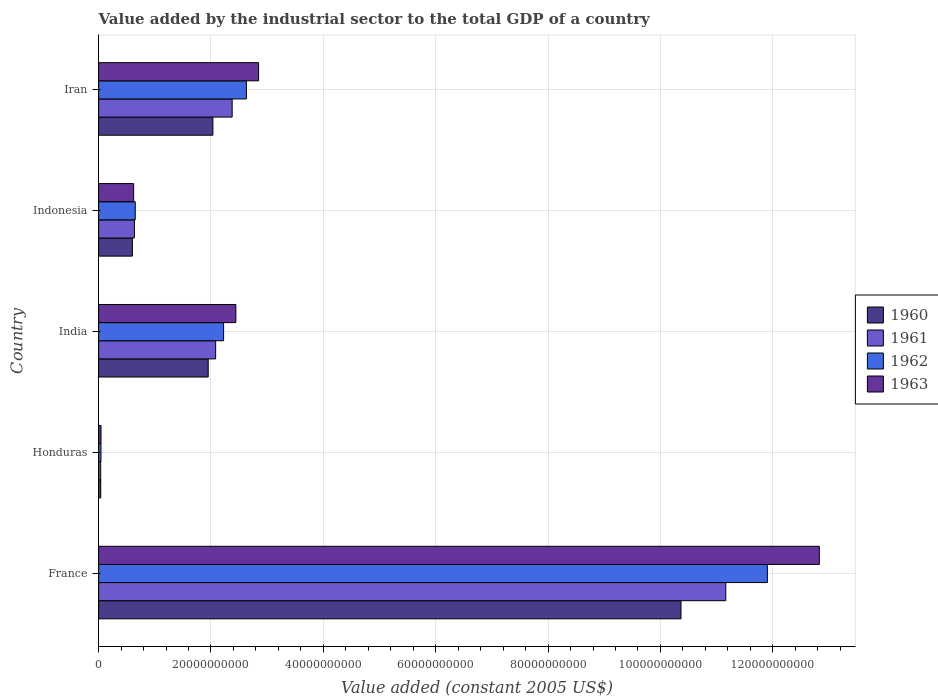How many bars are there on the 1st tick from the bottom?
Your answer should be very brief. 4. What is the value added by the industrial sector in 1960 in Honduras?
Give a very brief answer. 3.75e+08. Across all countries, what is the maximum value added by the industrial sector in 1961?
Keep it short and to the point. 1.12e+11. Across all countries, what is the minimum value added by the industrial sector in 1962?
Your answer should be very brief. 4.16e+08. In which country was the value added by the industrial sector in 1961 minimum?
Your answer should be compact. Honduras. What is the total value added by the industrial sector in 1962 in the graph?
Provide a short and direct response. 1.75e+11. What is the difference between the value added by the industrial sector in 1961 in Honduras and that in Iran?
Your answer should be compact. -2.34e+1. What is the difference between the value added by the industrial sector in 1962 in France and the value added by the industrial sector in 1963 in Honduras?
Keep it short and to the point. 1.19e+11. What is the average value added by the industrial sector in 1962 per country?
Provide a short and direct response. 3.49e+1. What is the difference between the value added by the industrial sector in 1962 and value added by the industrial sector in 1961 in Honduras?
Keep it short and to the point. 5.00e+07. What is the ratio of the value added by the industrial sector in 1961 in Honduras to that in India?
Your response must be concise. 0.02. Is the difference between the value added by the industrial sector in 1962 in Indonesia and Iran greater than the difference between the value added by the industrial sector in 1961 in Indonesia and Iran?
Offer a very short reply. No. What is the difference between the highest and the second highest value added by the industrial sector in 1961?
Your answer should be compact. 8.79e+1. What is the difference between the highest and the lowest value added by the industrial sector in 1961?
Provide a short and direct response. 1.11e+11. In how many countries, is the value added by the industrial sector in 1962 greater than the average value added by the industrial sector in 1962 taken over all countries?
Provide a short and direct response. 1. Is it the case that in every country, the sum of the value added by the industrial sector in 1961 and value added by the industrial sector in 1963 is greater than the sum of value added by the industrial sector in 1960 and value added by the industrial sector in 1962?
Your response must be concise. No. What does the 3rd bar from the bottom in France represents?
Provide a succinct answer. 1962. Is it the case that in every country, the sum of the value added by the industrial sector in 1960 and value added by the industrial sector in 1963 is greater than the value added by the industrial sector in 1962?
Provide a succinct answer. Yes. How many bars are there?
Your response must be concise. 20. Does the graph contain any zero values?
Keep it short and to the point. No. Does the graph contain grids?
Your answer should be compact. Yes. What is the title of the graph?
Give a very brief answer. Value added by the industrial sector to the total GDP of a country. What is the label or title of the X-axis?
Your answer should be compact. Value added (constant 2005 US$). What is the label or title of the Y-axis?
Ensure brevity in your answer.  Country. What is the Value added (constant 2005 US$) of 1960 in France?
Provide a succinct answer. 1.04e+11. What is the Value added (constant 2005 US$) of 1961 in France?
Offer a terse response. 1.12e+11. What is the Value added (constant 2005 US$) of 1962 in France?
Offer a terse response. 1.19e+11. What is the Value added (constant 2005 US$) of 1963 in France?
Give a very brief answer. 1.28e+11. What is the Value added (constant 2005 US$) of 1960 in Honduras?
Offer a very short reply. 3.75e+08. What is the Value added (constant 2005 US$) of 1961 in Honduras?
Keep it short and to the point. 3.66e+08. What is the Value added (constant 2005 US$) of 1962 in Honduras?
Your response must be concise. 4.16e+08. What is the Value added (constant 2005 US$) in 1963 in Honduras?
Provide a short and direct response. 4.23e+08. What is the Value added (constant 2005 US$) of 1960 in India?
Ensure brevity in your answer.  1.95e+1. What is the Value added (constant 2005 US$) in 1961 in India?
Offer a very short reply. 2.08e+1. What is the Value added (constant 2005 US$) of 1962 in India?
Make the answer very short. 2.22e+1. What is the Value added (constant 2005 US$) in 1963 in India?
Keep it short and to the point. 2.44e+1. What is the Value added (constant 2005 US$) of 1960 in Indonesia?
Give a very brief answer. 6.01e+09. What is the Value added (constant 2005 US$) in 1961 in Indonesia?
Keep it short and to the point. 6.37e+09. What is the Value added (constant 2005 US$) in 1962 in Indonesia?
Provide a short and direct response. 6.52e+09. What is the Value added (constant 2005 US$) of 1963 in Indonesia?
Give a very brief answer. 6.23e+09. What is the Value added (constant 2005 US$) in 1960 in Iran?
Ensure brevity in your answer.  2.03e+1. What is the Value added (constant 2005 US$) in 1961 in Iran?
Keep it short and to the point. 2.38e+1. What is the Value added (constant 2005 US$) in 1962 in Iran?
Your response must be concise. 2.63e+1. What is the Value added (constant 2005 US$) in 1963 in Iran?
Give a very brief answer. 2.85e+1. Across all countries, what is the maximum Value added (constant 2005 US$) in 1960?
Make the answer very short. 1.04e+11. Across all countries, what is the maximum Value added (constant 2005 US$) in 1961?
Offer a very short reply. 1.12e+11. Across all countries, what is the maximum Value added (constant 2005 US$) of 1962?
Offer a very short reply. 1.19e+11. Across all countries, what is the maximum Value added (constant 2005 US$) in 1963?
Give a very brief answer. 1.28e+11. Across all countries, what is the minimum Value added (constant 2005 US$) in 1960?
Offer a very short reply. 3.75e+08. Across all countries, what is the minimum Value added (constant 2005 US$) of 1961?
Offer a terse response. 3.66e+08. Across all countries, what is the minimum Value added (constant 2005 US$) of 1962?
Your answer should be very brief. 4.16e+08. Across all countries, what is the minimum Value added (constant 2005 US$) of 1963?
Provide a short and direct response. 4.23e+08. What is the total Value added (constant 2005 US$) in 1960 in the graph?
Keep it short and to the point. 1.50e+11. What is the total Value added (constant 2005 US$) in 1961 in the graph?
Your answer should be compact. 1.63e+11. What is the total Value added (constant 2005 US$) in 1962 in the graph?
Provide a succinct answer. 1.75e+11. What is the total Value added (constant 2005 US$) in 1963 in the graph?
Make the answer very short. 1.88e+11. What is the difference between the Value added (constant 2005 US$) in 1960 in France and that in Honduras?
Provide a short and direct response. 1.03e+11. What is the difference between the Value added (constant 2005 US$) in 1961 in France and that in Honduras?
Provide a succinct answer. 1.11e+11. What is the difference between the Value added (constant 2005 US$) in 1962 in France and that in Honduras?
Offer a terse response. 1.19e+11. What is the difference between the Value added (constant 2005 US$) in 1963 in France and that in Honduras?
Make the answer very short. 1.28e+11. What is the difference between the Value added (constant 2005 US$) of 1960 in France and that in India?
Your answer should be very brief. 8.42e+1. What is the difference between the Value added (constant 2005 US$) in 1961 in France and that in India?
Make the answer very short. 9.08e+1. What is the difference between the Value added (constant 2005 US$) in 1962 in France and that in India?
Your answer should be compact. 9.68e+1. What is the difference between the Value added (constant 2005 US$) of 1963 in France and that in India?
Your answer should be very brief. 1.04e+11. What is the difference between the Value added (constant 2005 US$) of 1960 in France and that in Indonesia?
Offer a very short reply. 9.77e+1. What is the difference between the Value added (constant 2005 US$) in 1961 in France and that in Indonesia?
Your answer should be compact. 1.05e+11. What is the difference between the Value added (constant 2005 US$) in 1962 in France and that in Indonesia?
Keep it short and to the point. 1.13e+11. What is the difference between the Value added (constant 2005 US$) of 1963 in France and that in Indonesia?
Your answer should be very brief. 1.22e+11. What is the difference between the Value added (constant 2005 US$) in 1960 in France and that in Iran?
Your answer should be very brief. 8.33e+1. What is the difference between the Value added (constant 2005 US$) in 1961 in France and that in Iran?
Give a very brief answer. 8.79e+1. What is the difference between the Value added (constant 2005 US$) in 1962 in France and that in Iran?
Your answer should be very brief. 9.27e+1. What is the difference between the Value added (constant 2005 US$) in 1963 in France and that in Iran?
Your response must be concise. 9.98e+1. What is the difference between the Value added (constant 2005 US$) in 1960 in Honduras and that in India?
Ensure brevity in your answer.  -1.91e+1. What is the difference between the Value added (constant 2005 US$) in 1961 in Honduras and that in India?
Give a very brief answer. -2.05e+1. What is the difference between the Value added (constant 2005 US$) in 1962 in Honduras and that in India?
Provide a succinct answer. -2.18e+1. What is the difference between the Value added (constant 2005 US$) of 1963 in Honduras and that in India?
Ensure brevity in your answer.  -2.40e+1. What is the difference between the Value added (constant 2005 US$) in 1960 in Honduras and that in Indonesia?
Your answer should be compact. -5.63e+09. What is the difference between the Value added (constant 2005 US$) of 1961 in Honduras and that in Indonesia?
Your answer should be compact. -6.00e+09. What is the difference between the Value added (constant 2005 US$) in 1962 in Honduras and that in Indonesia?
Give a very brief answer. -6.10e+09. What is the difference between the Value added (constant 2005 US$) of 1963 in Honduras and that in Indonesia?
Offer a very short reply. -5.81e+09. What is the difference between the Value added (constant 2005 US$) of 1960 in Honduras and that in Iran?
Provide a succinct answer. -2.00e+1. What is the difference between the Value added (constant 2005 US$) in 1961 in Honduras and that in Iran?
Your answer should be very brief. -2.34e+1. What is the difference between the Value added (constant 2005 US$) of 1962 in Honduras and that in Iran?
Provide a succinct answer. -2.59e+1. What is the difference between the Value added (constant 2005 US$) of 1963 in Honduras and that in Iran?
Provide a short and direct response. -2.81e+1. What is the difference between the Value added (constant 2005 US$) of 1960 in India and that in Indonesia?
Your answer should be compact. 1.35e+1. What is the difference between the Value added (constant 2005 US$) of 1961 in India and that in Indonesia?
Ensure brevity in your answer.  1.45e+1. What is the difference between the Value added (constant 2005 US$) of 1962 in India and that in Indonesia?
Your answer should be very brief. 1.57e+1. What is the difference between the Value added (constant 2005 US$) in 1963 in India and that in Indonesia?
Provide a succinct answer. 1.82e+1. What is the difference between the Value added (constant 2005 US$) in 1960 in India and that in Iran?
Your answer should be compact. -8.36e+08. What is the difference between the Value added (constant 2005 US$) of 1961 in India and that in Iran?
Ensure brevity in your answer.  -2.94e+09. What is the difference between the Value added (constant 2005 US$) in 1962 in India and that in Iran?
Make the answer very short. -4.06e+09. What is the difference between the Value added (constant 2005 US$) in 1963 in India and that in Iran?
Your answer should be compact. -4.05e+09. What is the difference between the Value added (constant 2005 US$) in 1960 in Indonesia and that in Iran?
Make the answer very short. -1.43e+1. What is the difference between the Value added (constant 2005 US$) in 1961 in Indonesia and that in Iran?
Offer a very short reply. -1.74e+1. What is the difference between the Value added (constant 2005 US$) in 1962 in Indonesia and that in Iran?
Provide a short and direct response. -1.98e+1. What is the difference between the Value added (constant 2005 US$) of 1963 in Indonesia and that in Iran?
Give a very brief answer. -2.22e+1. What is the difference between the Value added (constant 2005 US$) in 1960 in France and the Value added (constant 2005 US$) in 1961 in Honduras?
Offer a very short reply. 1.03e+11. What is the difference between the Value added (constant 2005 US$) of 1960 in France and the Value added (constant 2005 US$) of 1962 in Honduras?
Your response must be concise. 1.03e+11. What is the difference between the Value added (constant 2005 US$) in 1960 in France and the Value added (constant 2005 US$) in 1963 in Honduras?
Offer a very short reply. 1.03e+11. What is the difference between the Value added (constant 2005 US$) in 1961 in France and the Value added (constant 2005 US$) in 1962 in Honduras?
Offer a terse response. 1.11e+11. What is the difference between the Value added (constant 2005 US$) in 1961 in France and the Value added (constant 2005 US$) in 1963 in Honduras?
Your answer should be compact. 1.11e+11. What is the difference between the Value added (constant 2005 US$) of 1962 in France and the Value added (constant 2005 US$) of 1963 in Honduras?
Make the answer very short. 1.19e+11. What is the difference between the Value added (constant 2005 US$) in 1960 in France and the Value added (constant 2005 US$) in 1961 in India?
Your answer should be very brief. 8.28e+1. What is the difference between the Value added (constant 2005 US$) of 1960 in France and the Value added (constant 2005 US$) of 1962 in India?
Your answer should be very brief. 8.14e+1. What is the difference between the Value added (constant 2005 US$) in 1960 in France and the Value added (constant 2005 US$) in 1963 in India?
Your response must be concise. 7.92e+1. What is the difference between the Value added (constant 2005 US$) of 1961 in France and the Value added (constant 2005 US$) of 1962 in India?
Offer a terse response. 8.94e+1. What is the difference between the Value added (constant 2005 US$) of 1961 in France and the Value added (constant 2005 US$) of 1963 in India?
Offer a terse response. 8.72e+1. What is the difference between the Value added (constant 2005 US$) in 1962 in France and the Value added (constant 2005 US$) in 1963 in India?
Keep it short and to the point. 9.46e+1. What is the difference between the Value added (constant 2005 US$) in 1960 in France and the Value added (constant 2005 US$) in 1961 in Indonesia?
Keep it short and to the point. 9.73e+1. What is the difference between the Value added (constant 2005 US$) of 1960 in France and the Value added (constant 2005 US$) of 1962 in Indonesia?
Your answer should be very brief. 9.71e+1. What is the difference between the Value added (constant 2005 US$) of 1960 in France and the Value added (constant 2005 US$) of 1963 in Indonesia?
Offer a terse response. 9.74e+1. What is the difference between the Value added (constant 2005 US$) of 1961 in France and the Value added (constant 2005 US$) of 1962 in Indonesia?
Make the answer very short. 1.05e+11. What is the difference between the Value added (constant 2005 US$) in 1961 in France and the Value added (constant 2005 US$) in 1963 in Indonesia?
Give a very brief answer. 1.05e+11. What is the difference between the Value added (constant 2005 US$) in 1962 in France and the Value added (constant 2005 US$) in 1963 in Indonesia?
Your response must be concise. 1.13e+11. What is the difference between the Value added (constant 2005 US$) of 1960 in France and the Value added (constant 2005 US$) of 1961 in Iran?
Offer a terse response. 7.99e+1. What is the difference between the Value added (constant 2005 US$) in 1960 in France and the Value added (constant 2005 US$) in 1962 in Iran?
Provide a succinct answer. 7.74e+1. What is the difference between the Value added (constant 2005 US$) in 1960 in France and the Value added (constant 2005 US$) in 1963 in Iran?
Give a very brief answer. 7.52e+1. What is the difference between the Value added (constant 2005 US$) in 1961 in France and the Value added (constant 2005 US$) in 1962 in Iran?
Keep it short and to the point. 8.53e+1. What is the difference between the Value added (constant 2005 US$) of 1961 in France and the Value added (constant 2005 US$) of 1963 in Iran?
Keep it short and to the point. 8.32e+1. What is the difference between the Value added (constant 2005 US$) in 1962 in France and the Value added (constant 2005 US$) in 1963 in Iran?
Give a very brief answer. 9.06e+1. What is the difference between the Value added (constant 2005 US$) of 1960 in Honduras and the Value added (constant 2005 US$) of 1961 in India?
Make the answer very short. -2.05e+1. What is the difference between the Value added (constant 2005 US$) of 1960 in Honduras and the Value added (constant 2005 US$) of 1962 in India?
Make the answer very short. -2.19e+1. What is the difference between the Value added (constant 2005 US$) of 1960 in Honduras and the Value added (constant 2005 US$) of 1963 in India?
Keep it short and to the point. -2.41e+1. What is the difference between the Value added (constant 2005 US$) in 1961 in Honduras and the Value added (constant 2005 US$) in 1962 in India?
Keep it short and to the point. -2.19e+1. What is the difference between the Value added (constant 2005 US$) in 1961 in Honduras and the Value added (constant 2005 US$) in 1963 in India?
Your response must be concise. -2.41e+1. What is the difference between the Value added (constant 2005 US$) in 1962 in Honduras and the Value added (constant 2005 US$) in 1963 in India?
Provide a short and direct response. -2.40e+1. What is the difference between the Value added (constant 2005 US$) in 1960 in Honduras and the Value added (constant 2005 US$) in 1961 in Indonesia?
Keep it short and to the point. -5.99e+09. What is the difference between the Value added (constant 2005 US$) of 1960 in Honduras and the Value added (constant 2005 US$) of 1962 in Indonesia?
Provide a succinct answer. -6.14e+09. What is the difference between the Value added (constant 2005 US$) of 1960 in Honduras and the Value added (constant 2005 US$) of 1963 in Indonesia?
Keep it short and to the point. -5.85e+09. What is the difference between the Value added (constant 2005 US$) in 1961 in Honduras and the Value added (constant 2005 US$) in 1962 in Indonesia?
Give a very brief answer. -6.15e+09. What is the difference between the Value added (constant 2005 US$) of 1961 in Honduras and the Value added (constant 2005 US$) of 1963 in Indonesia?
Ensure brevity in your answer.  -5.86e+09. What is the difference between the Value added (constant 2005 US$) in 1962 in Honduras and the Value added (constant 2005 US$) in 1963 in Indonesia?
Keep it short and to the point. -5.81e+09. What is the difference between the Value added (constant 2005 US$) in 1960 in Honduras and the Value added (constant 2005 US$) in 1961 in Iran?
Offer a terse response. -2.34e+1. What is the difference between the Value added (constant 2005 US$) of 1960 in Honduras and the Value added (constant 2005 US$) of 1962 in Iran?
Make the answer very short. -2.59e+1. What is the difference between the Value added (constant 2005 US$) of 1960 in Honduras and the Value added (constant 2005 US$) of 1963 in Iran?
Provide a succinct answer. -2.81e+1. What is the difference between the Value added (constant 2005 US$) of 1961 in Honduras and the Value added (constant 2005 US$) of 1962 in Iran?
Offer a very short reply. -2.59e+1. What is the difference between the Value added (constant 2005 US$) in 1961 in Honduras and the Value added (constant 2005 US$) in 1963 in Iran?
Your answer should be compact. -2.81e+1. What is the difference between the Value added (constant 2005 US$) of 1962 in Honduras and the Value added (constant 2005 US$) of 1963 in Iran?
Provide a short and direct response. -2.81e+1. What is the difference between the Value added (constant 2005 US$) of 1960 in India and the Value added (constant 2005 US$) of 1961 in Indonesia?
Give a very brief answer. 1.31e+1. What is the difference between the Value added (constant 2005 US$) in 1960 in India and the Value added (constant 2005 US$) in 1962 in Indonesia?
Keep it short and to the point. 1.30e+1. What is the difference between the Value added (constant 2005 US$) in 1960 in India and the Value added (constant 2005 US$) in 1963 in Indonesia?
Provide a succinct answer. 1.33e+1. What is the difference between the Value added (constant 2005 US$) in 1961 in India and the Value added (constant 2005 US$) in 1962 in Indonesia?
Offer a very short reply. 1.43e+1. What is the difference between the Value added (constant 2005 US$) of 1961 in India and the Value added (constant 2005 US$) of 1963 in Indonesia?
Make the answer very short. 1.46e+1. What is the difference between the Value added (constant 2005 US$) of 1962 in India and the Value added (constant 2005 US$) of 1963 in Indonesia?
Give a very brief answer. 1.60e+1. What is the difference between the Value added (constant 2005 US$) in 1960 in India and the Value added (constant 2005 US$) in 1961 in Iran?
Provide a short and direct response. -4.27e+09. What is the difference between the Value added (constant 2005 US$) of 1960 in India and the Value added (constant 2005 US$) of 1962 in Iran?
Ensure brevity in your answer.  -6.80e+09. What is the difference between the Value added (constant 2005 US$) in 1960 in India and the Value added (constant 2005 US$) in 1963 in Iran?
Offer a terse response. -8.97e+09. What is the difference between the Value added (constant 2005 US$) in 1961 in India and the Value added (constant 2005 US$) in 1962 in Iran?
Give a very brief answer. -5.48e+09. What is the difference between the Value added (constant 2005 US$) in 1961 in India and the Value added (constant 2005 US$) in 1963 in Iran?
Your answer should be compact. -7.65e+09. What is the difference between the Value added (constant 2005 US$) in 1962 in India and the Value added (constant 2005 US$) in 1963 in Iran?
Offer a terse response. -6.23e+09. What is the difference between the Value added (constant 2005 US$) in 1960 in Indonesia and the Value added (constant 2005 US$) in 1961 in Iran?
Give a very brief answer. -1.78e+1. What is the difference between the Value added (constant 2005 US$) of 1960 in Indonesia and the Value added (constant 2005 US$) of 1962 in Iran?
Offer a terse response. -2.03e+1. What is the difference between the Value added (constant 2005 US$) of 1960 in Indonesia and the Value added (constant 2005 US$) of 1963 in Iran?
Your answer should be compact. -2.25e+1. What is the difference between the Value added (constant 2005 US$) of 1961 in Indonesia and the Value added (constant 2005 US$) of 1962 in Iran?
Give a very brief answer. -1.99e+1. What is the difference between the Value added (constant 2005 US$) in 1961 in Indonesia and the Value added (constant 2005 US$) in 1963 in Iran?
Your answer should be compact. -2.21e+1. What is the difference between the Value added (constant 2005 US$) of 1962 in Indonesia and the Value added (constant 2005 US$) of 1963 in Iran?
Provide a succinct answer. -2.20e+1. What is the average Value added (constant 2005 US$) of 1960 per country?
Give a very brief answer. 3.00e+1. What is the average Value added (constant 2005 US$) in 1961 per country?
Your response must be concise. 3.26e+1. What is the average Value added (constant 2005 US$) of 1962 per country?
Offer a very short reply. 3.49e+1. What is the average Value added (constant 2005 US$) in 1963 per country?
Ensure brevity in your answer.  3.76e+1. What is the difference between the Value added (constant 2005 US$) of 1960 and Value added (constant 2005 US$) of 1961 in France?
Offer a very short reply. -7.97e+09. What is the difference between the Value added (constant 2005 US$) in 1960 and Value added (constant 2005 US$) in 1962 in France?
Make the answer very short. -1.54e+1. What is the difference between the Value added (constant 2005 US$) of 1960 and Value added (constant 2005 US$) of 1963 in France?
Provide a succinct answer. -2.46e+1. What is the difference between the Value added (constant 2005 US$) of 1961 and Value added (constant 2005 US$) of 1962 in France?
Offer a very short reply. -7.41e+09. What is the difference between the Value added (constant 2005 US$) of 1961 and Value added (constant 2005 US$) of 1963 in France?
Provide a short and direct response. -1.67e+1. What is the difference between the Value added (constant 2005 US$) of 1962 and Value added (constant 2005 US$) of 1963 in France?
Your response must be concise. -9.25e+09. What is the difference between the Value added (constant 2005 US$) in 1960 and Value added (constant 2005 US$) in 1961 in Honduras?
Provide a short and direct response. 9.37e+06. What is the difference between the Value added (constant 2005 US$) of 1960 and Value added (constant 2005 US$) of 1962 in Honduras?
Ensure brevity in your answer.  -4.07e+07. What is the difference between the Value added (constant 2005 US$) of 1960 and Value added (constant 2005 US$) of 1963 in Honduras?
Provide a succinct answer. -4.79e+07. What is the difference between the Value added (constant 2005 US$) of 1961 and Value added (constant 2005 US$) of 1962 in Honduras?
Provide a succinct answer. -5.00e+07. What is the difference between the Value added (constant 2005 US$) of 1961 and Value added (constant 2005 US$) of 1963 in Honduras?
Make the answer very short. -5.72e+07. What is the difference between the Value added (constant 2005 US$) of 1962 and Value added (constant 2005 US$) of 1963 in Honduras?
Ensure brevity in your answer.  -7.19e+06. What is the difference between the Value added (constant 2005 US$) in 1960 and Value added (constant 2005 US$) in 1961 in India?
Keep it short and to the point. -1.32e+09. What is the difference between the Value added (constant 2005 US$) in 1960 and Value added (constant 2005 US$) in 1962 in India?
Your answer should be very brief. -2.74e+09. What is the difference between the Value added (constant 2005 US$) in 1960 and Value added (constant 2005 US$) in 1963 in India?
Your response must be concise. -4.92e+09. What is the difference between the Value added (constant 2005 US$) in 1961 and Value added (constant 2005 US$) in 1962 in India?
Your answer should be very brief. -1.42e+09. What is the difference between the Value added (constant 2005 US$) in 1961 and Value added (constant 2005 US$) in 1963 in India?
Offer a very short reply. -3.60e+09. What is the difference between the Value added (constant 2005 US$) in 1962 and Value added (constant 2005 US$) in 1963 in India?
Make the answer very short. -2.18e+09. What is the difference between the Value added (constant 2005 US$) of 1960 and Value added (constant 2005 US$) of 1961 in Indonesia?
Ensure brevity in your answer.  -3.60e+08. What is the difference between the Value added (constant 2005 US$) in 1960 and Value added (constant 2005 US$) in 1962 in Indonesia?
Your response must be concise. -5.10e+08. What is the difference between the Value added (constant 2005 US$) in 1960 and Value added (constant 2005 US$) in 1963 in Indonesia?
Offer a very short reply. -2.22e+08. What is the difference between the Value added (constant 2005 US$) of 1961 and Value added (constant 2005 US$) of 1962 in Indonesia?
Offer a very short reply. -1.50e+08. What is the difference between the Value added (constant 2005 US$) in 1961 and Value added (constant 2005 US$) in 1963 in Indonesia?
Offer a terse response. 1.38e+08. What is the difference between the Value added (constant 2005 US$) in 1962 and Value added (constant 2005 US$) in 1963 in Indonesia?
Ensure brevity in your answer.  2.88e+08. What is the difference between the Value added (constant 2005 US$) in 1960 and Value added (constant 2005 US$) in 1961 in Iran?
Provide a short and direct response. -3.43e+09. What is the difference between the Value added (constant 2005 US$) in 1960 and Value added (constant 2005 US$) in 1962 in Iran?
Offer a terse response. -5.96e+09. What is the difference between the Value added (constant 2005 US$) of 1960 and Value added (constant 2005 US$) of 1963 in Iran?
Offer a very short reply. -8.14e+09. What is the difference between the Value added (constant 2005 US$) of 1961 and Value added (constant 2005 US$) of 1962 in Iran?
Your answer should be compact. -2.53e+09. What is the difference between the Value added (constant 2005 US$) in 1961 and Value added (constant 2005 US$) in 1963 in Iran?
Give a very brief answer. -4.71e+09. What is the difference between the Value added (constant 2005 US$) in 1962 and Value added (constant 2005 US$) in 1963 in Iran?
Provide a succinct answer. -2.17e+09. What is the ratio of the Value added (constant 2005 US$) in 1960 in France to that in Honduras?
Your response must be concise. 276.31. What is the ratio of the Value added (constant 2005 US$) in 1961 in France to that in Honduras?
Your answer should be very brief. 305.16. What is the ratio of the Value added (constant 2005 US$) in 1962 in France to that in Honduras?
Your answer should be very brief. 286.26. What is the ratio of the Value added (constant 2005 US$) of 1963 in France to that in Honduras?
Make the answer very short. 303.25. What is the ratio of the Value added (constant 2005 US$) of 1960 in France to that in India?
Offer a terse response. 5.32. What is the ratio of the Value added (constant 2005 US$) in 1961 in France to that in India?
Give a very brief answer. 5.36. What is the ratio of the Value added (constant 2005 US$) of 1962 in France to that in India?
Give a very brief answer. 5.35. What is the ratio of the Value added (constant 2005 US$) of 1963 in France to that in India?
Your answer should be very brief. 5.25. What is the ratio of the Value added (constant 2005 US$) of 1960 in France to that in Indonesia?
Ensure brevity in your answer.  17.26. What is the ratio of the Value added (constant 2005 US$) of 1961 in France to that in Indonesia?
Make the answer very short. 17.53. What is the ratio of the Value added (constant 2005 US$) in 1962 in France to that in Indonesia?
Provide a short and direct response. 18.27. What is the ratio of the Value added (constant 2005 US$) of 1963 in France to that in Indonesia?
Provide a short and direct response. 20.59. What is the ratio of the Value added (constant 2005 US$) in 1960 in France to that in Iran?
Provide a succinct answer. 5.1. What is the ratio of the Value added (constant 2005 US$) of 1961 in France to that in Iran?
Give a very brief answer. 4.7. What is the ratio of the Value added (constant 2005 US$) of 1962 in France to that in Iran?
Make the answer very short. 4.53. What is the ratio of the Value added (constant 2005 US$) of 1963 in France to that in Iran?
Give a very brief answer. 4.51. What is the ratio of the Value added (constant 2005 US$) of 1960 in Honduras to that in India?
Offer a very short reply. 0.02. What is the ratio of the Value added (constant 2005 US$) in 1961 in Honduras to that in India?
Offer a terse response. 0.02. What is the ratio of the Value added (constant 2005 US$) in 1962 in Honduras to that in India?
Provide a succinct answer. 0.02. What is the ratio of the Value added (constant 2005 US$) of 1963 in Honduras to that in India?
Your answer should be compact. 0.02. What is the ratio of the Value added (constant 2005 US$) in 1960 in Honduras to that in Indonesia?
Ensure brevity in your answer.  0.06. What is the ratio of the Value added (constant 2005 US$) in 1961 in Honduras to that in Indonesia?
Your response must be concise. 0.06. What is the ratio of the Value added (constant 2005 US$) of 1962 in Honduras to that in Indonesia?
Keep it short and to the point. 0.06. What is the ratio of the Value added (constant 2005 US$) of 1963 in Honduras to that in Indonesia?
Ensure brevity in your answer.  0.07. What is the ratio of the Value added (constant 2005 US$) of 1960 in Honduras to that in Iran?
Give a very brief answer. 0.02. What is the ratio of the Value added (constant 2005 US$) in 1961 in Honduras to that in Iran?
Offer a very short reply. 0.02. What is the ratio of the Value added (constant 2005 US$) of 1962 in Honduras to that in Iran?
Your answer should be very brief. 0.02. What is the ratio of the Value added (constant 2005 US$) in 1963 in Honduras to that in Iran?
Your response must be concise. 0.01. What is the ratio of the Value added (constant 2005 US$) of 1960 in India to that in Indonesia?
Your answer should be very brief. 3.25. What is the ratio of the Value added (constant 2005 US$) of 1961 in India to that in Indonesia?
Give a very brief answer. 3.27. What is the ratio of the Value added (constant 2005 US$) of 1962 in India to that in Indonesia?
Offer a terse response. 3.41. What is the ratio of the Value added (constant 2005 US$) of 1963 in India to that in Indonesia?
Provide a short and direct response. 3.92. What is the ratio of the Value added (constant 2005 US$) of 1960 in India to that in Iran?
Your response must be concise. 0.96. What is the ratio of the Value added (constant 2005 US$) in 1961 in India to that in Iran?
Your answer should be compact. 0.88. What is the ratio of the Value added (constant 2005 US$) in 1962 in India to that in Iran?
Your response must be concise. 0.85. What is the ratio of the Value added (constant 2005 US$) in 1963 in India to that in Iran?
Your answer should be compact. 0.86. What is the ratio of the Value added (constant 2005 US$) of 1960 in Indonesia to that in Iran?
Ensure brevity in your answer.  0.3. What is the ratio of the Value added (constant 2005 US$) of 1961 in Indonesia to that in Iran?
Provide a short and direct response. 0.27. What is the ratio of the Value added (constant 2005 US$) of 1962 in Indonesia to that in Iran?
Keep it short and to the point. 0.25. What is the ratio of the Value added (constant 2005 US$) of 1963 in Indonesia to that in Iran?
Ensure brevity in your answer.  0.22. What is the difference between the highest and the second highest Value added (constant 2005 US$) of 1960?
Your answer should be very brief. 8.33e+1. What is the difference between the highest and the second highest Value added (constant 2005 US$) of 1961?
Keep it short and to the point. 8.79e+1. What is the difference between the highest and the second highest Value added (constant 2005 US$) of 1962?
Ensure brevity in your answer.  9.27e+1. What is the difference between the highest and the second highest Value added (constant 2005 US$) in 1963?
Keep it short and to the point. 9.98e+1. What is the difference between the highest and the lowest Value added (constant 2005 US$) in 1960?
Offer a terse response. 1.03e+11. What is the difference between the highest and the lowest Value added (constant 2005 US$) of 1961?
Your answer should be compact. 1.11e+11. What is the difference between the highest and the lowest Value added (constant 2005 US$) in 1962?
Keep it short and to the point. 1.19e+11. What is the difference between the highest and the lowest Value added (constant 2005 US$) in 1963?
Your response must be concise. 1.28e+11. 